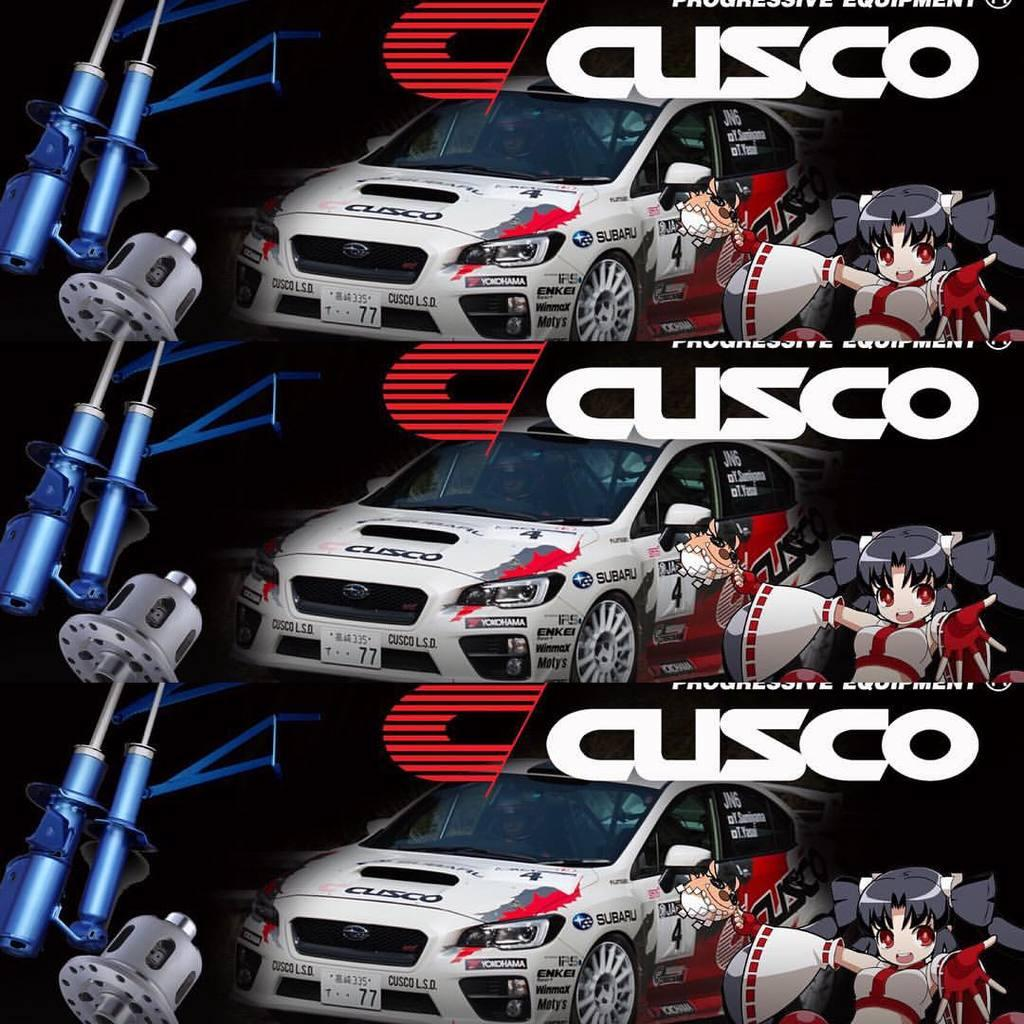What is featured on the poster in the image? The facts provided do not specify what is on the poster. What type of vehicles can be seen in the image? There are cars in the image. Can you describe the people in the image? The facts provided do not specify the characteristics of the people in the image. What other objects are present in the image besides the poster and cars? There are other objects in the image. How many clams are visible on the poster in the image? There are no clams visible on the poster in the image, as the facts provided do not mention any clams. 